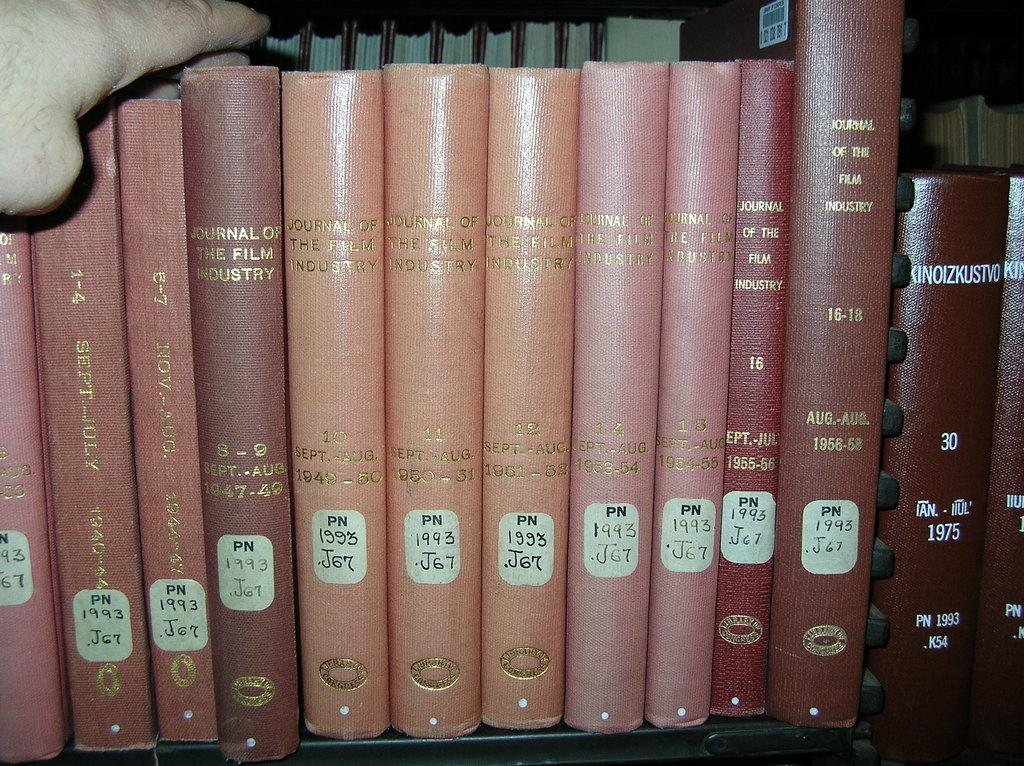Provide a one-sentence caption for the provided image. A row of books including Journal of the Film Industry. 